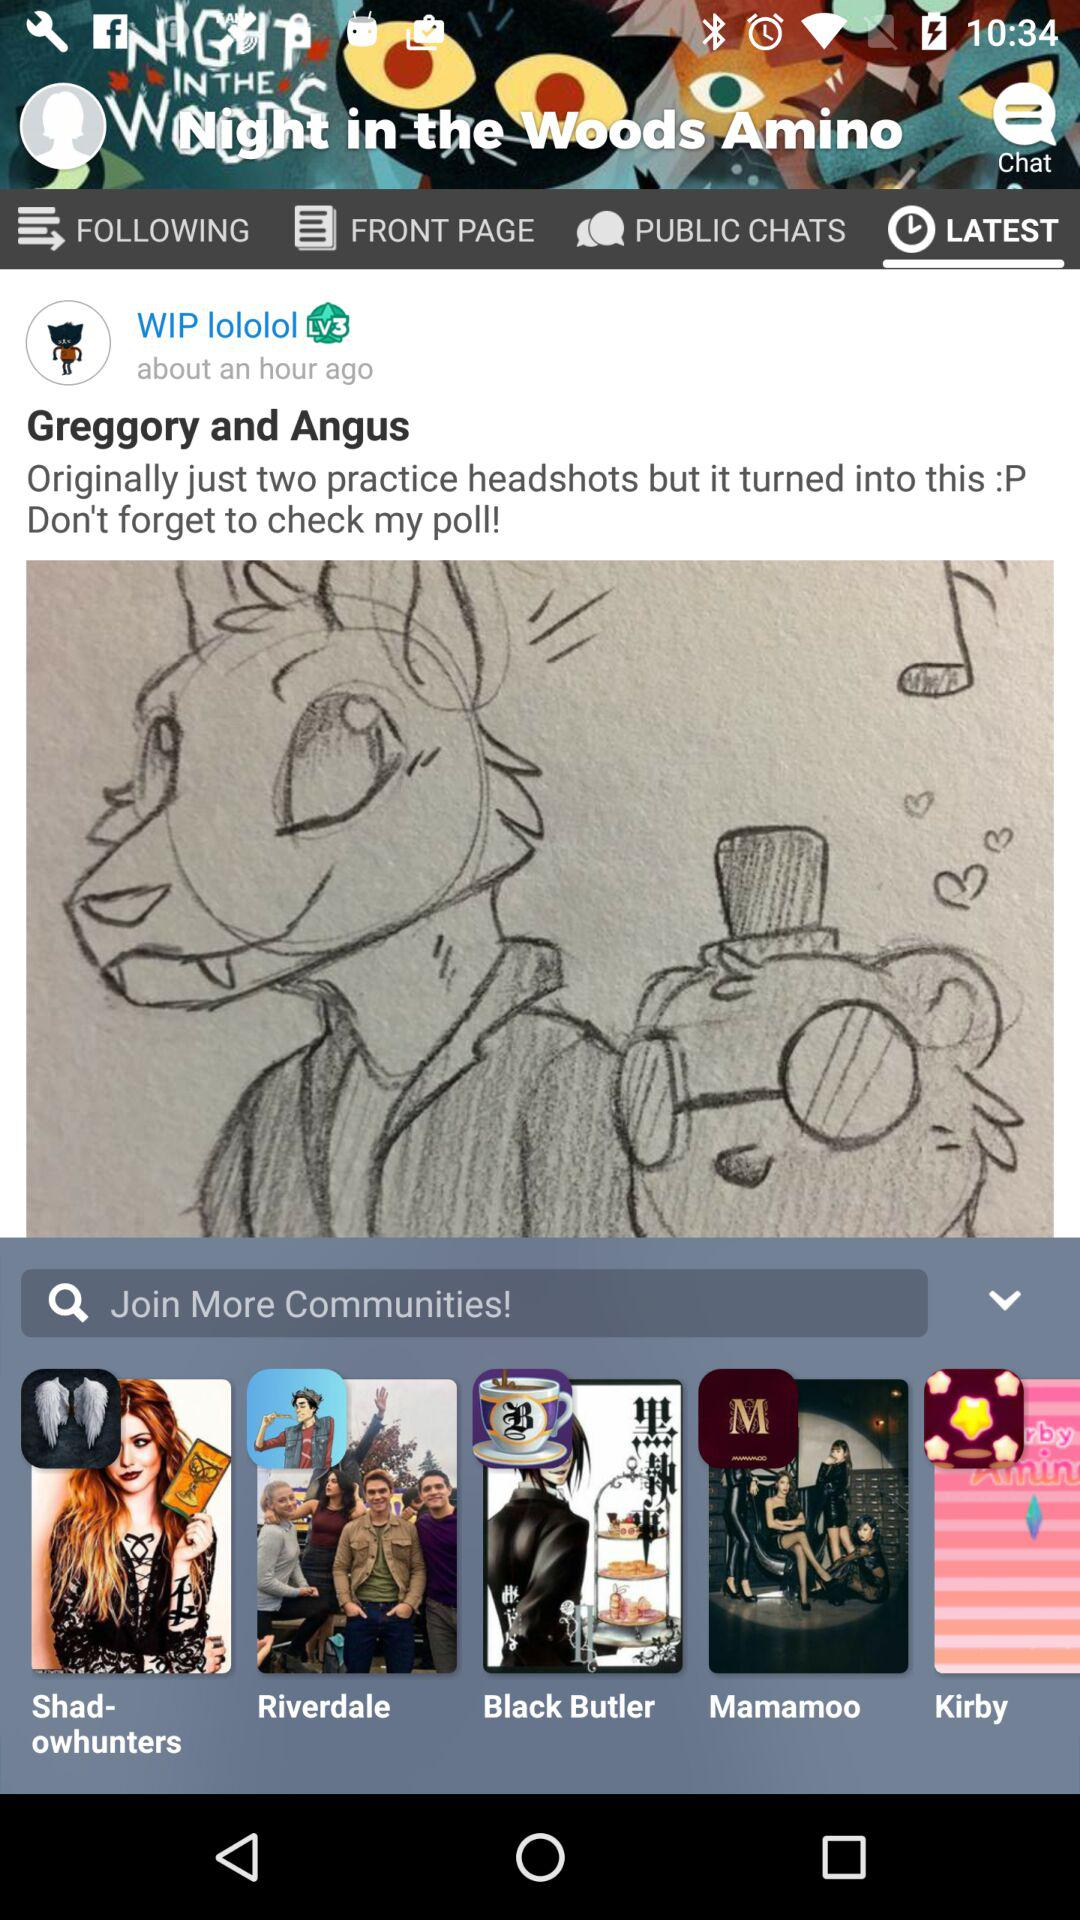How many hours ago did "WIP lololol" post? "WIP lololol" posted about an hour ago. 